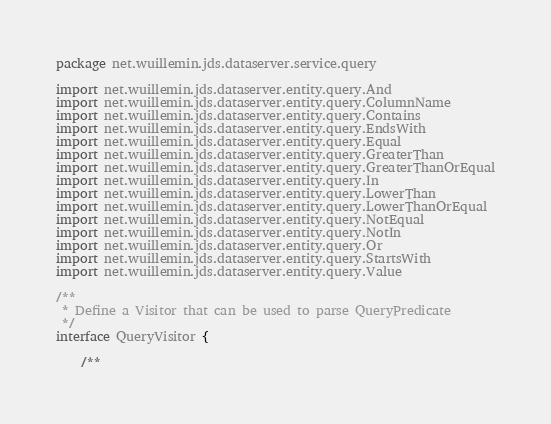<code> <loc_0><loc_0><loc_500><loc_500><_Kotlin_>package net.wuillemin.jds.dataserver.service.query

import net.wuillemin.jds.dataserver.entity.query.And
import net.wuillemin.jds.dataserver.entity.query.ColumnName
import net.wuillemin.jds.dataserver.entity.query.Contains
import net.wuillemin.jds.dataserver.entity.query.EndsWith
import net.wuillemin.jds.dataserver.entity.query.Equal
import net.wuillemin.jds.dataserver.entity.query.GreaterThan
import net.wuillemin.jds.dataserver.entity.query.GreaterThanOrEqual
import net.wuillemin.jds.dataserver.entity.query.In
import net.wuillemin.jds.dataserver.entity.query.LowerThan
import net.wuillemin.jds.dataserver.entity.query.LowerThanOrEqual
import net.wuillemin.jds.dataserver.entity.query.NotEqual
import net.wuillemin.jds.dataserver.entity.query.NotIn
import net.wuillemin.jds.dataserver.entity.query.Or
import net.wuillemin.jds.dataserver.entity.query.StartsWith
import net.wuillemin.jds.dataserver.entity.query.Value

/**
 * Define a Visitor that can be used to parse QueryPredicate
 */
interface QueryVisitor {

    /**</code> 